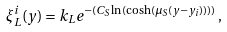Convert formula to latex. <formula><loc_0><loc_0><loc_500><loc_500>\xi _ { L } ^ { i } ( y ) = k _ { L } e ^ { - ( C _ { S } \ln ( \cosh ( \mu _ { S } ( y - y _ { i } ) ) ) ) } \, ,</formula> 